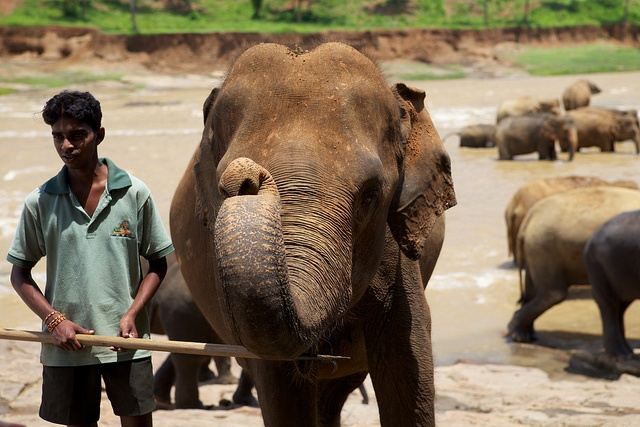Describe the objects in this image and their specific colors. I can see elephant in salmon, black, gray, and maroon tones, people in salmon, black, darkgray, gray, and maroon tones, elephant in tan, black, and gray tones, elephant in salmon, black, gray, and maroon tones, and elephant in salmon, black, maroon, and gray tones in this image. 